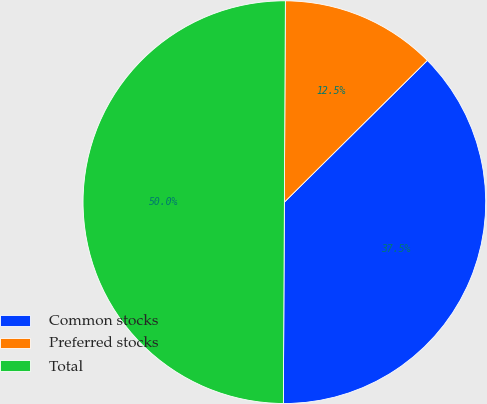Convert chart. <chart><loc_0><loc_0><loc_500><loc_500><pie_chart><fcel>Common stocks<fcel>Preferred stocks<fcel>Total<nl><fcel>37.51%<fcel>12.49%<fcel>50.0%<nl></chart> 